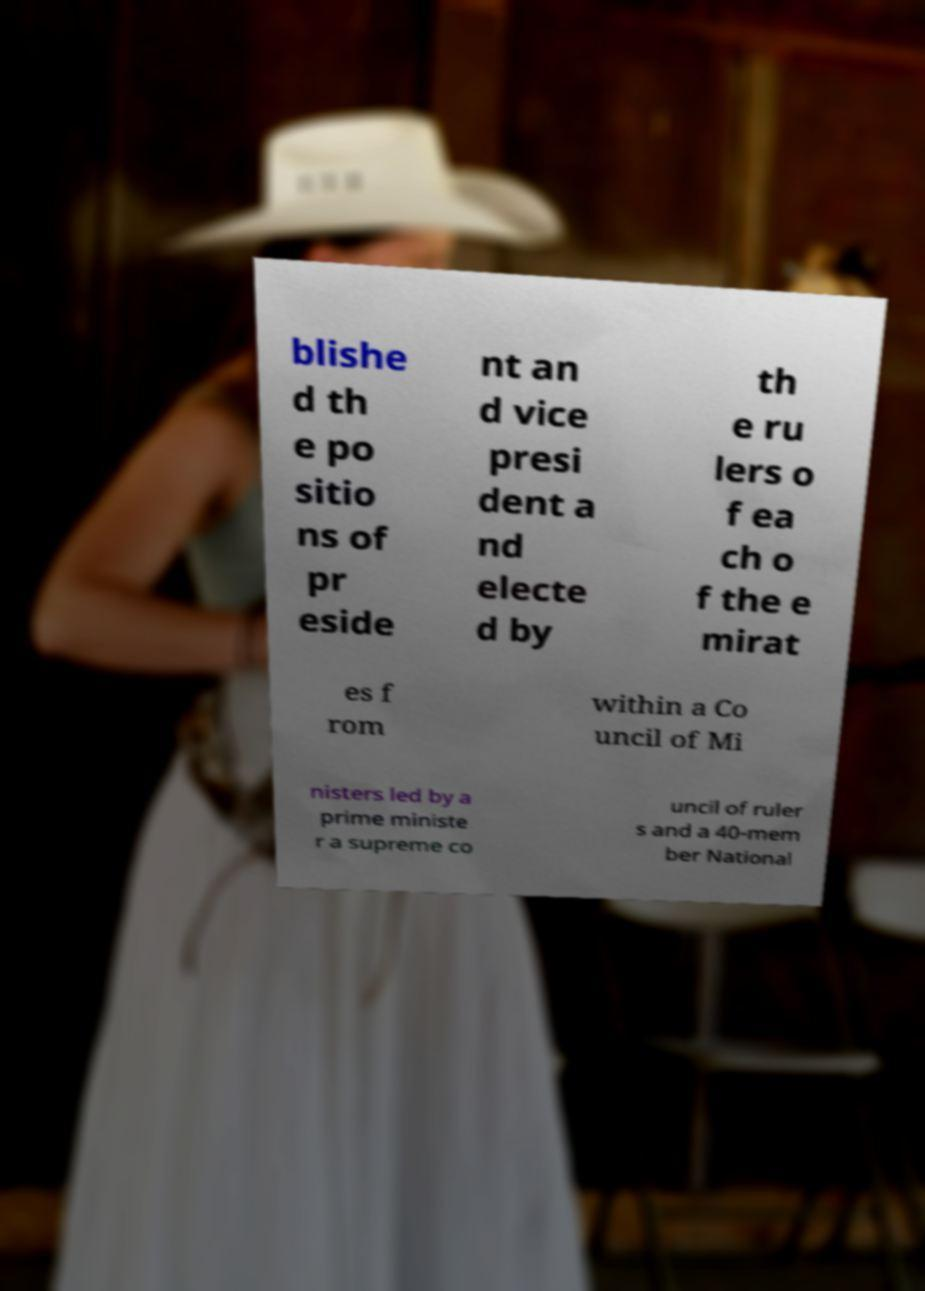Please read and relay the text visible in this image. What does it say? blishe d th e po sitio ns of pr eside nt an d vice presi dent a nd electe d by th e ru lers o f ea ch o f the e mirat es f rom within a Co uncil of Mi nisters led by a prime ministe r a supreme co uncil of ruler s and a 40-mem ber National 